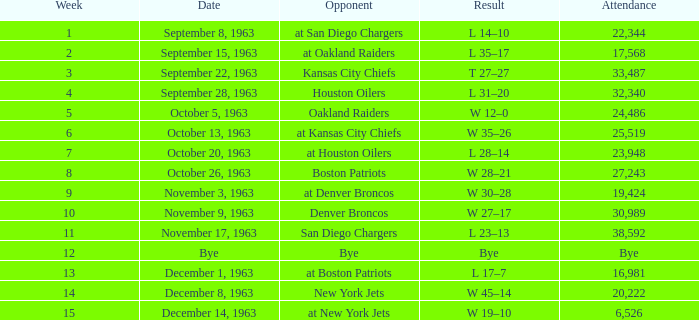Which Opponent has a Result of l 14–10? At san diego chargers. 